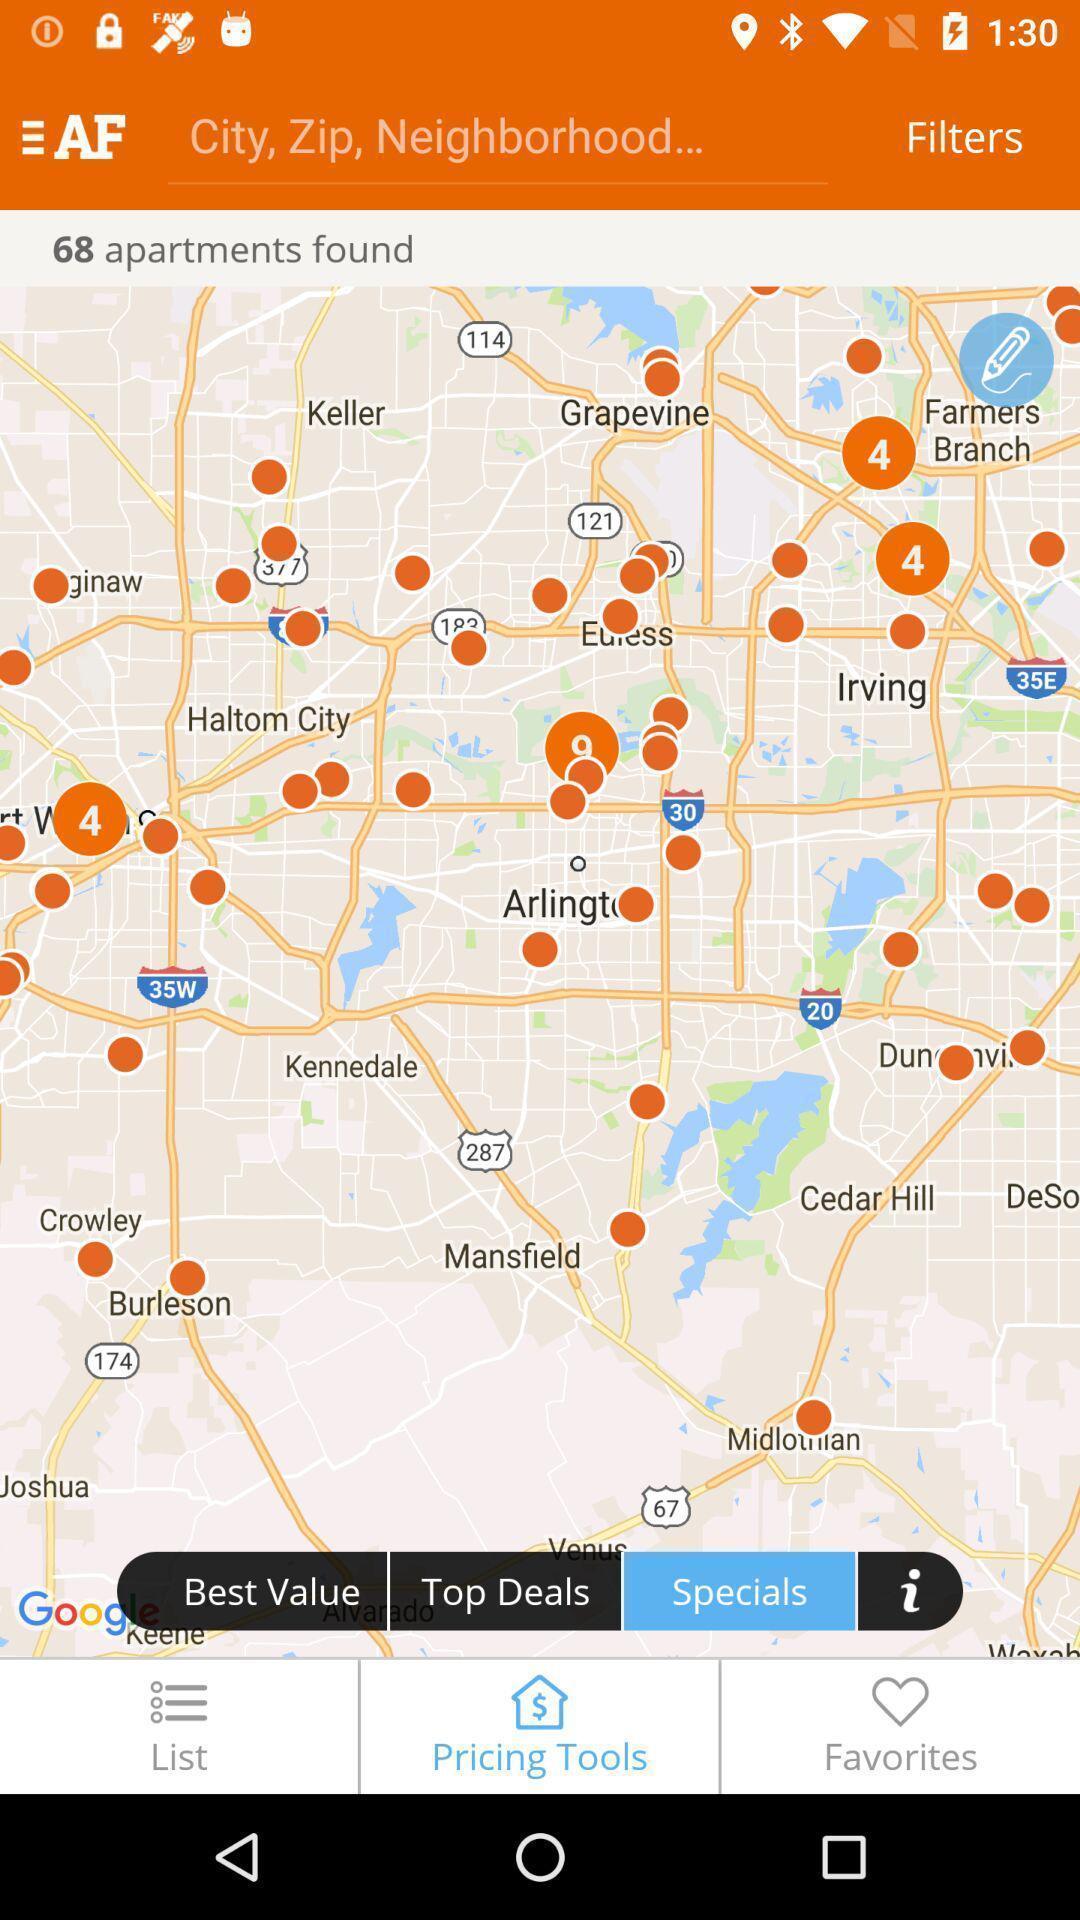Tell me what you see in this picture. Screen shows search city option. 